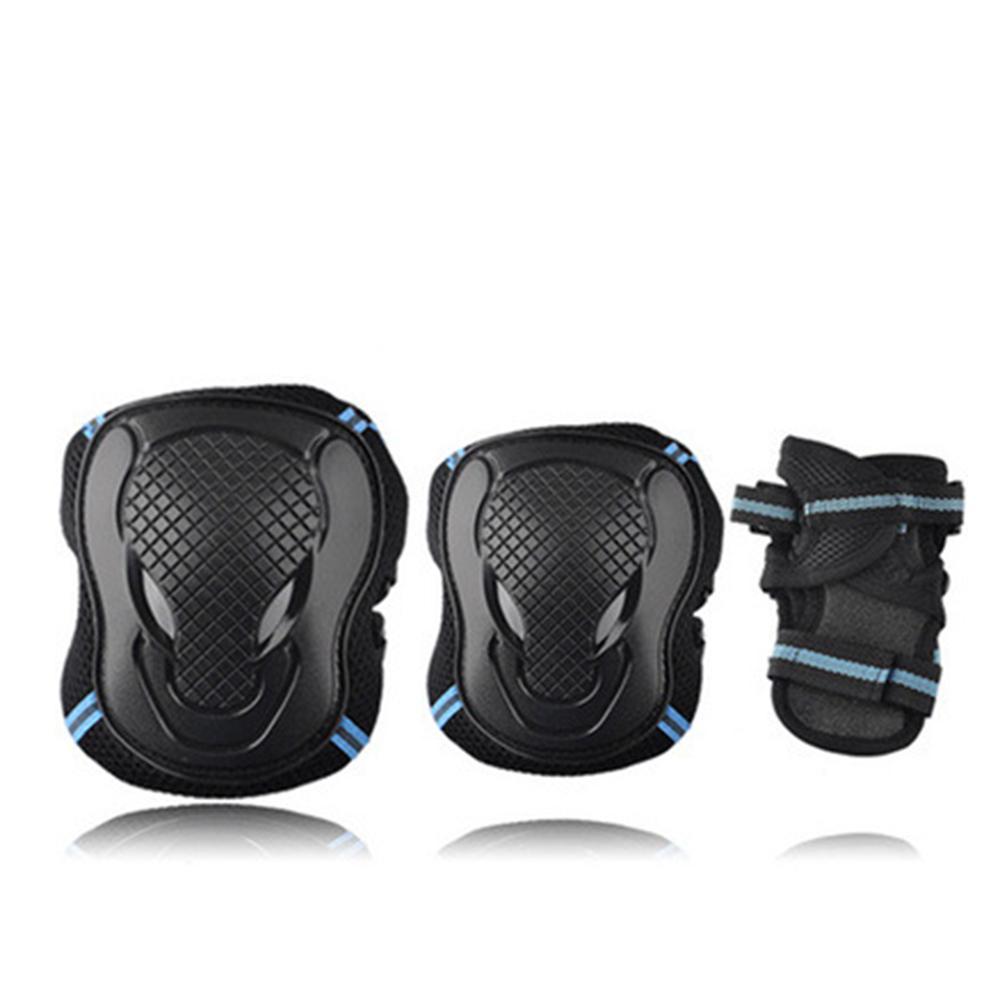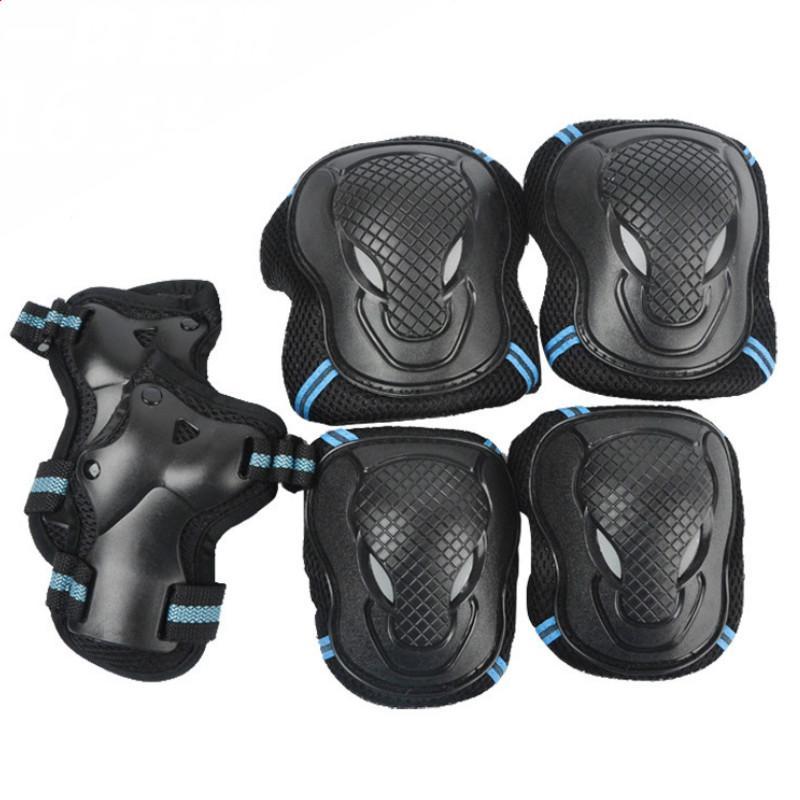The first image is the image on the left, the second image is the image on the right. For the images shown, is this caption "An image shows a set of three pairs of protective items, which are solid black with red on the logos." true? Answer yes or no. No. The first image is the image on the left, the second image is the image on the right. Examine the images to the left and right. Is the description "Some wrist braces are visible" accurate? Answer yes or no. No. 